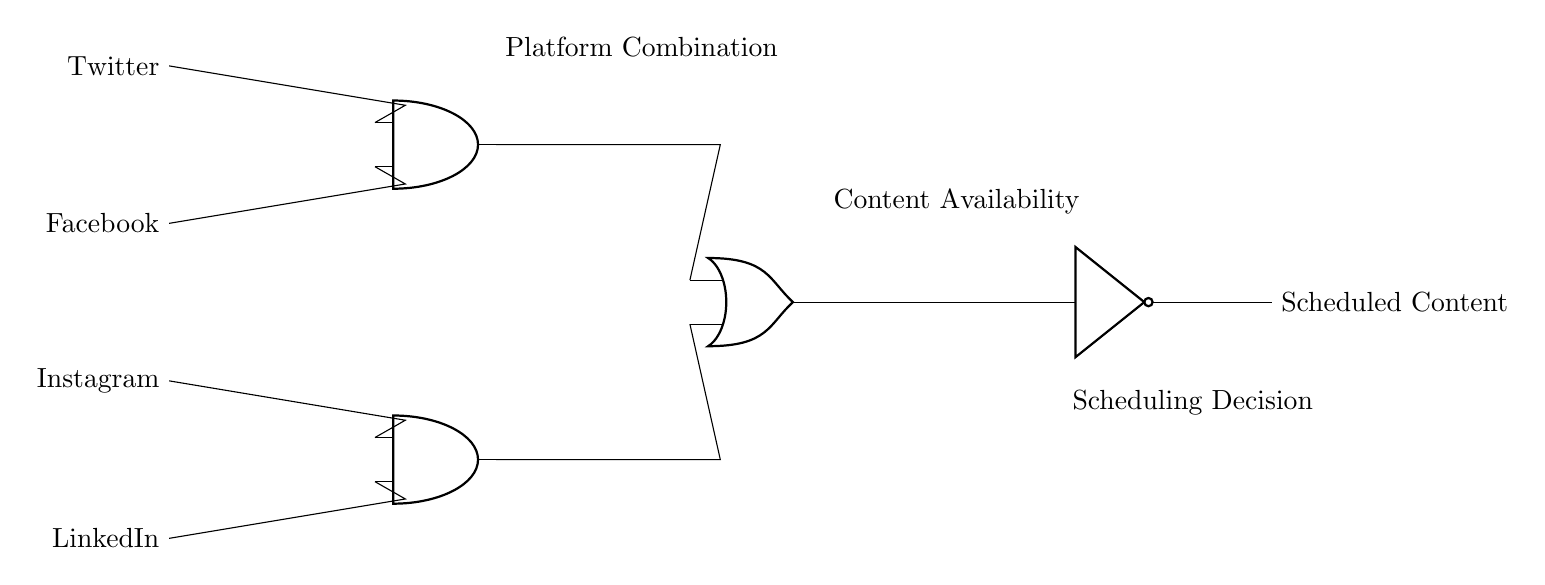What is the output of the circuit if all inputs are high? In this circuit, both AND gates require two high inputs to produce a high output. If all platforms (Twitter, Facebook, Instagram, LinkedIn) provide a high signal, both AND gates will output high. The OR gate will then also output high since at least one of its inputs is high. Thus, the NOT gate will output low, meaning the final output is low.
Answer: low What is the function of the OR gate in this circuit? The OR gate in this circuit combines the outputs of the two AND gates. If either of the AND gates outputs high, the OR gate will also output high. This allows for flexibility in content scheduling depending on the availability of content from either combination of platforms.
Answer: combines outputs How many input signals are connected to the AND gates? There are a total of four input signals connected to the AND gates: two connected to the first AND gate (Twitter and Facebook) and two to the second AND gate (Instagram and LinkedIn). Therefore, the total number of input signals is four.
Answer: four What happens if the Twitter input is low? If the Twitter input is low, the first AND gate will not be able to output a high signal, regardless of the state of the Facebook input. This means only the second AND gate, which takes inputs from Instagram and LinkedIn, can contribute a high signal to the OR gate, potentially affecting the final scheduled content output.
Answer: first AND gate low Which components are used to negate the output signal? The negation of the output signal is performed by the NOT gate in this circuit. The NOT gate takes the output from the OR gate and inverts it. If the OR gate outputs high, the NOT gate will output low, representing the final scheduling decision for the content.
Answer: NOT gate What logic operation do the AND gates represent? The AND gates in this circuit represent the logical AND operation, which requires all inputs to be high for the output to be high. This reflects the necessity for content availability from both platforms being considered by each AND gate to schedule content correctly.
Answer: logical AND 